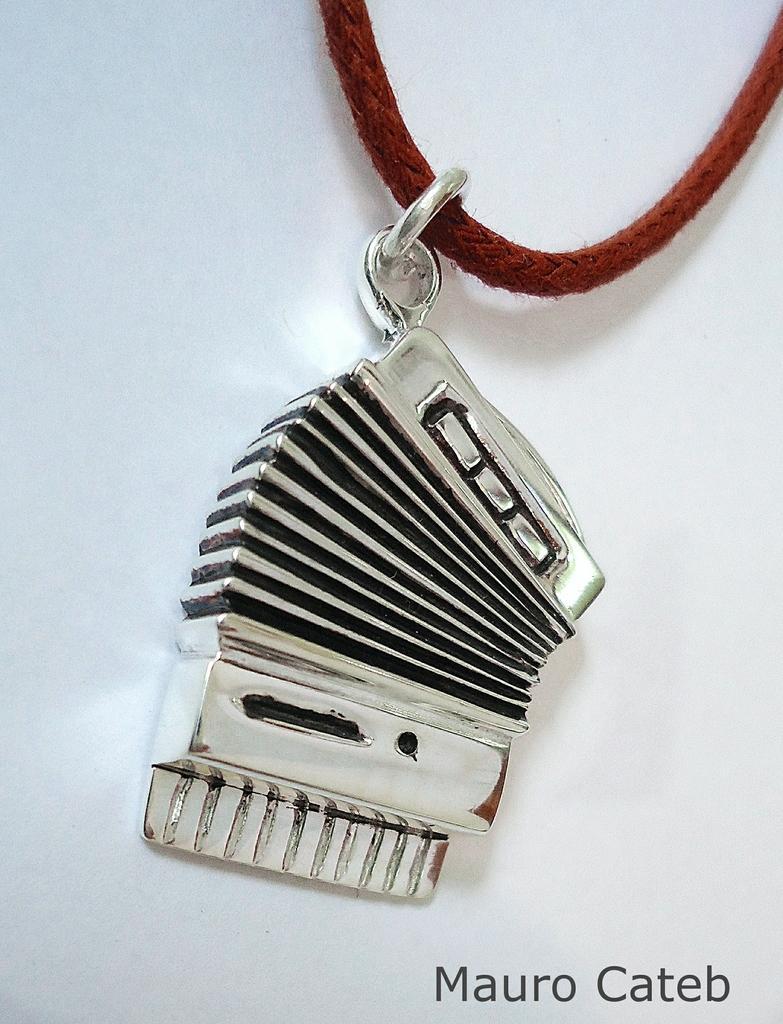In one or two sentences, can you explain what this image depicts? In this image there is an object to a thread. At the bottom of the image there is some text. Behind the object there is a wall. 